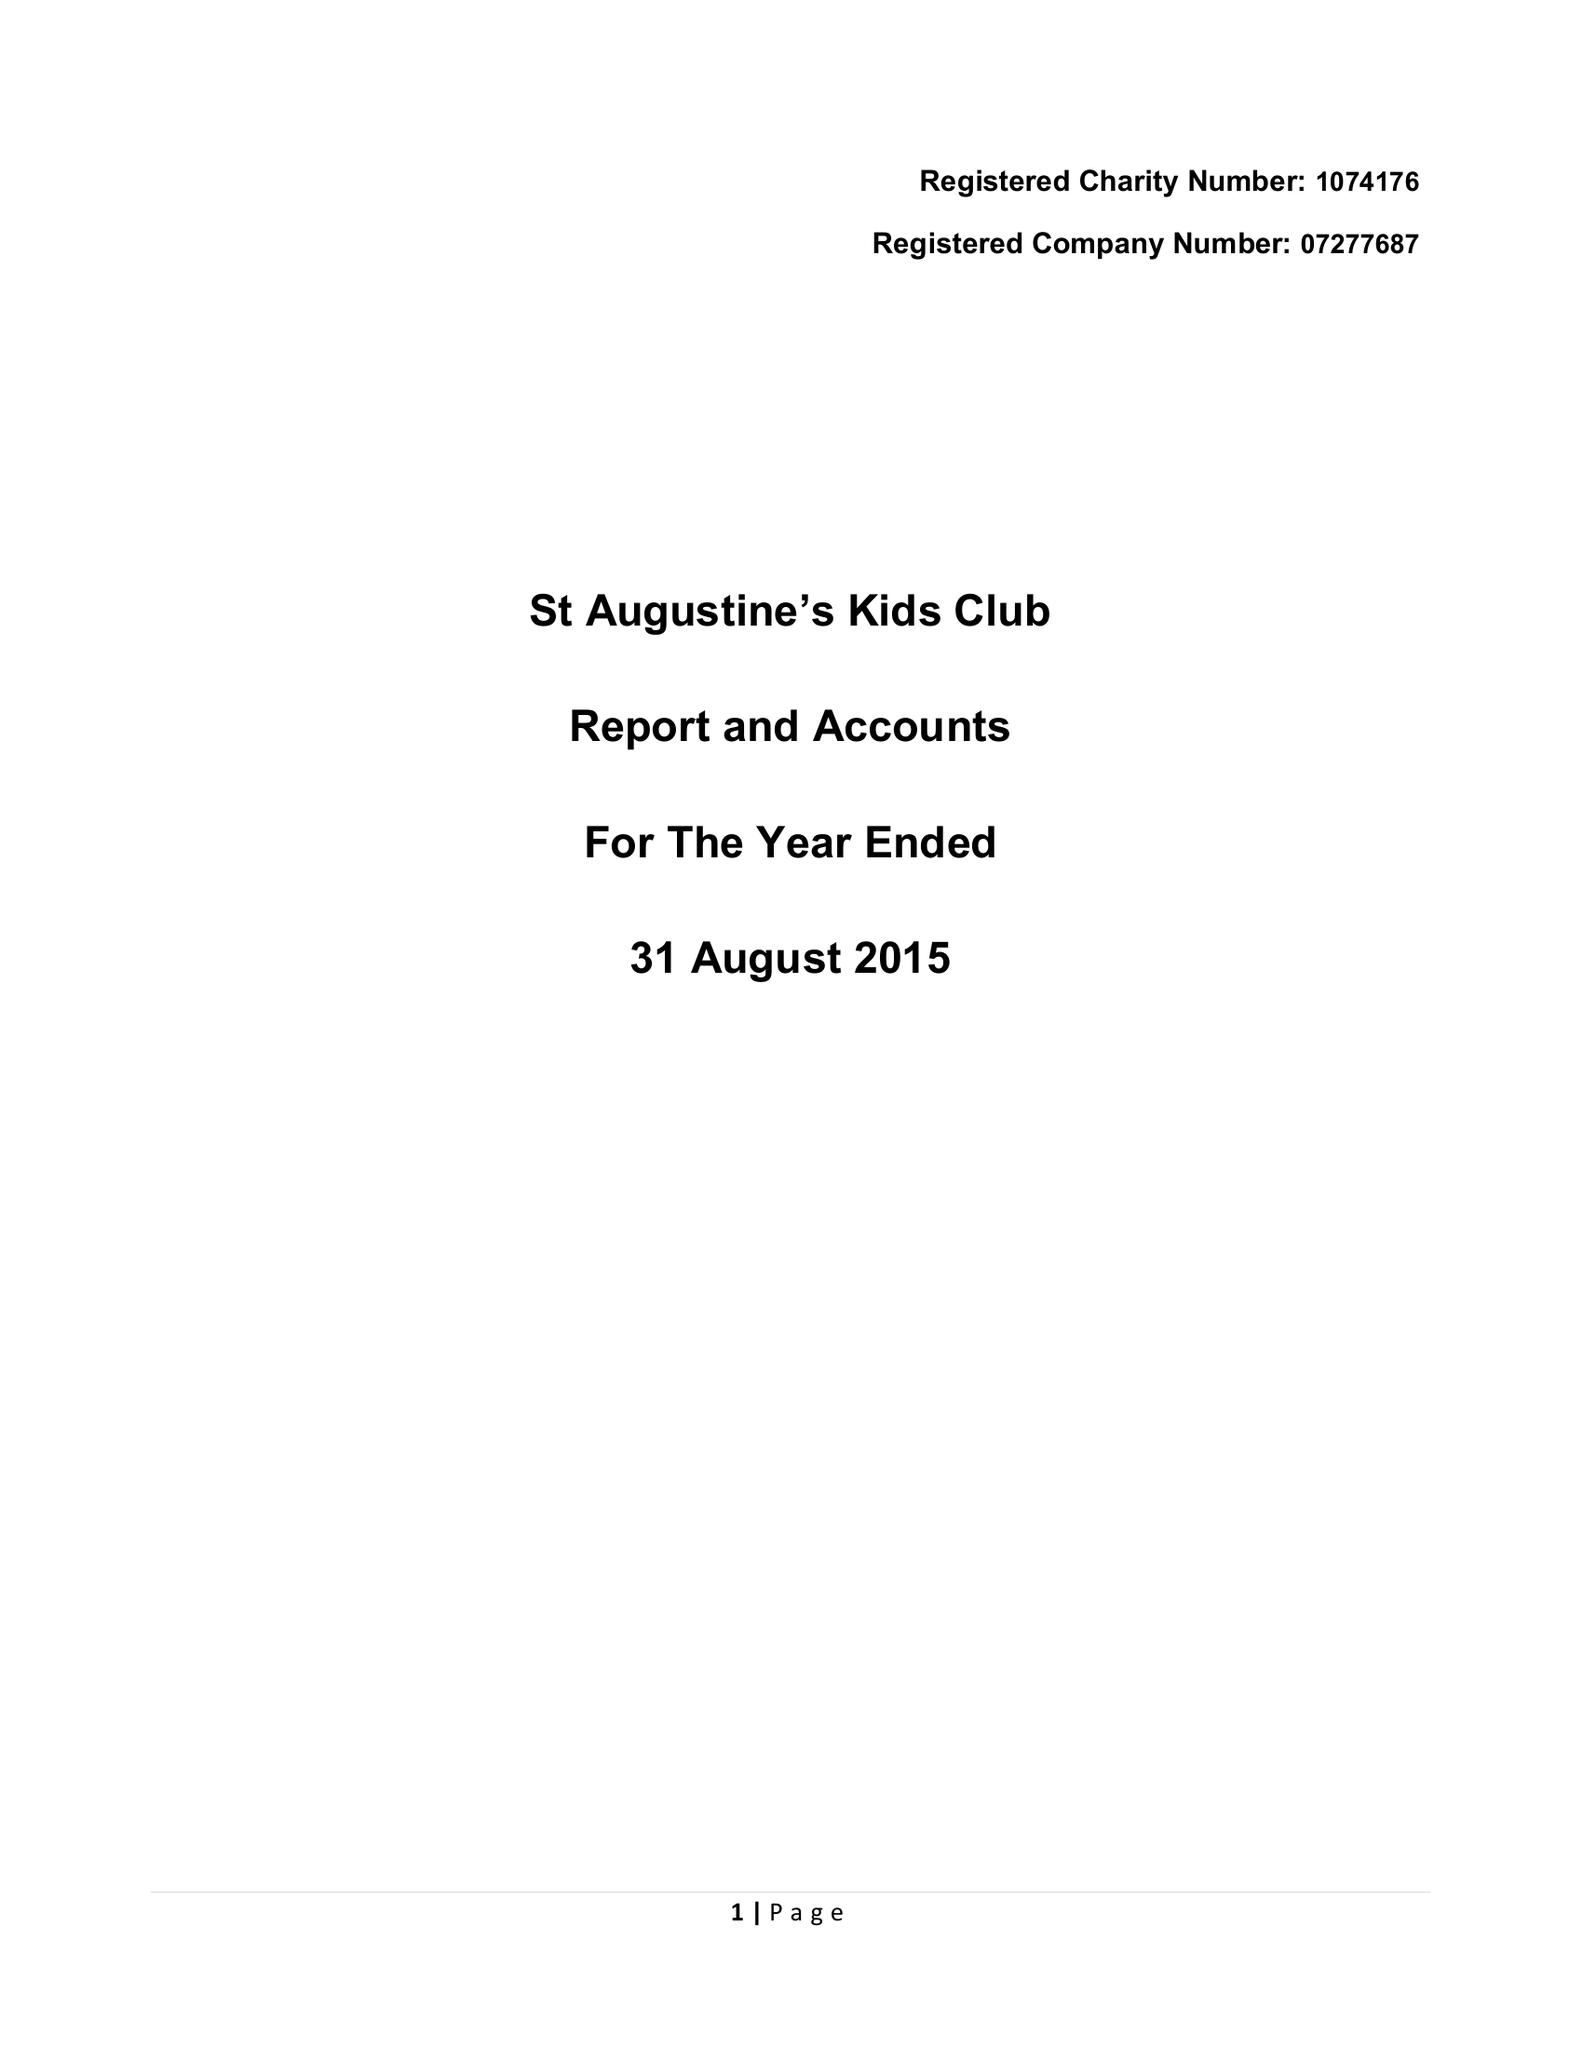What is the value for the charity_number?
Answer the question using a single word or phrase. 1074176 